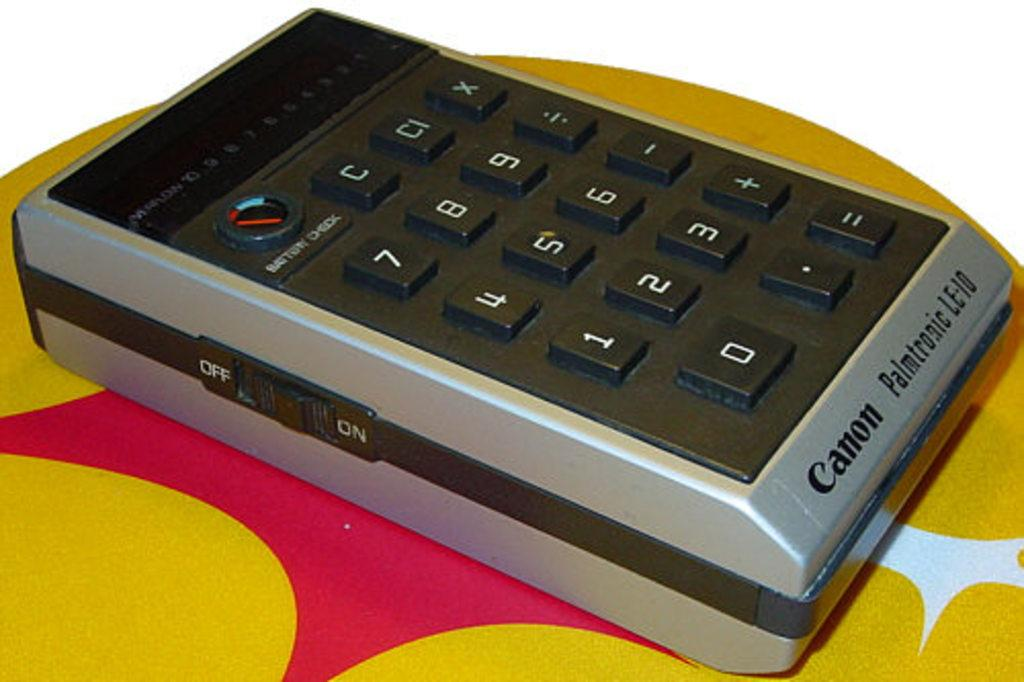<image>
Offer a succinct explanation of the picture presented. A Canon Palmtronic device sits on a yellow and pink background. 